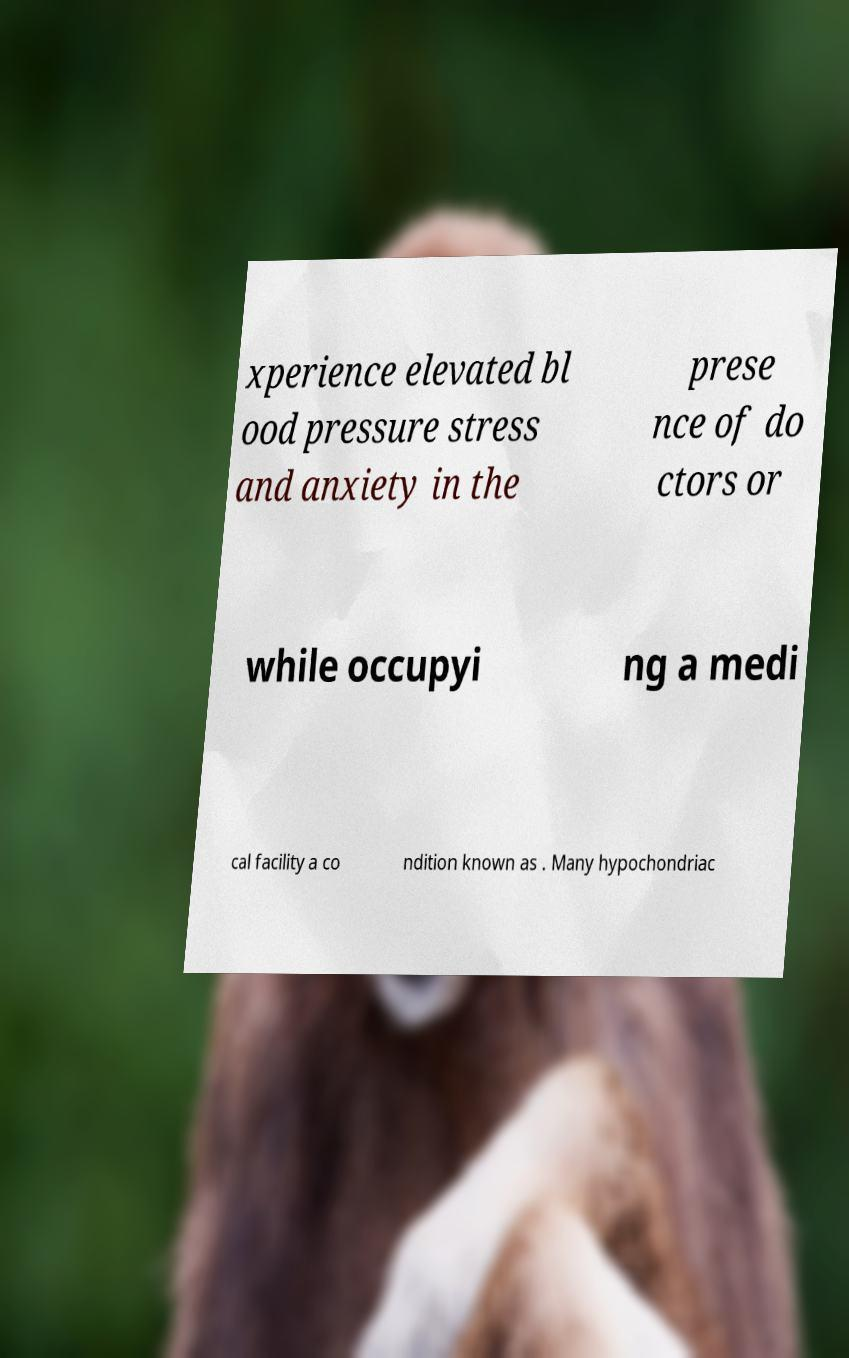There's text embedded in this image that I need extracted. Can you transcribe it verbatim? xperience elevated bl ood pressure stress and anxiety in the prese nce of do ctors or while occupyi ng a medi cal facility a co ndition known as . Many hypochondriac 